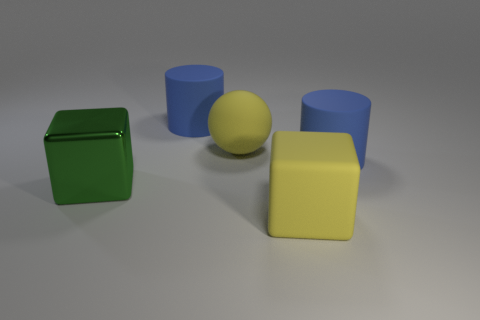Subtract all gray cubes. Subtract all red balls. How many cubes are left? 2 Add 1 tiny yellow matte things. How many objects exist? 6 Subtract all spheres. How many objects are left? 4 Add 1 yellow matte blocks. How many yellow matte blocks exist? 2 Subtract 0 cyan blocks. How many objects are left? 5 Subtract all big yellow rubber cubes. Subtract all large green metallic cylinders. How many objects are left? 4 Add 2 large green metal things. How many large green metal things are left? 3 